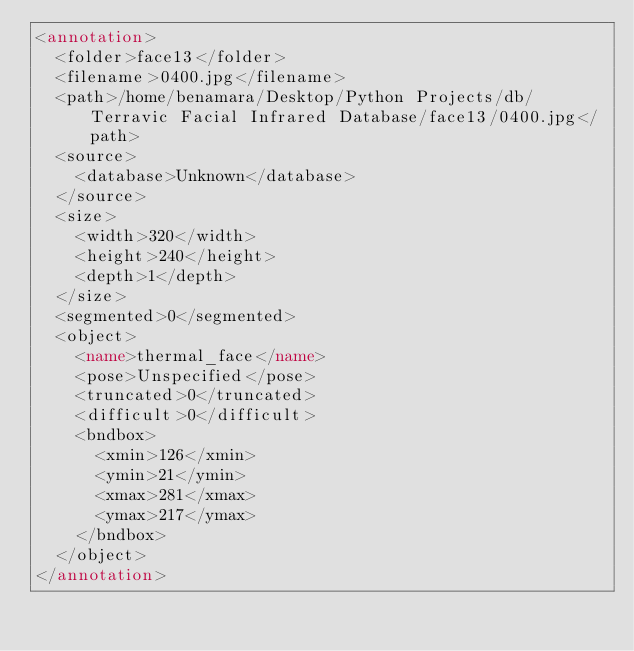<code> <loc_0><loc_0><loc_500><loc_500><_XML_><annotation>
	<folder>face13</folder>
	<filename>0400.jpg</filename>
	<path>/home/benamara/Desktop/Python Projects/db/Terravic Facial Infrared Database/face13/0400.jpg</path>
	<source>
		<database>Unknown</database>
	</source>
	<size>
		<width>320</width>
		<height>240</height>
		<depth>1</depth>
	</size>
	<segmented>0</segmented>
	<object>
		<name>thermal_face</name>
		<pose>Unspecified</pose>
		<truncated>0</truncated>
		<difficult>0</difficult>
		<bndbox>
			<xmin>126</xmin>
			<ymin>21</ymin>
			<xmax>281</xmax>
			<ymax>217</ymax>
		</bndbox>
	</object>
</annotation>
</code> 